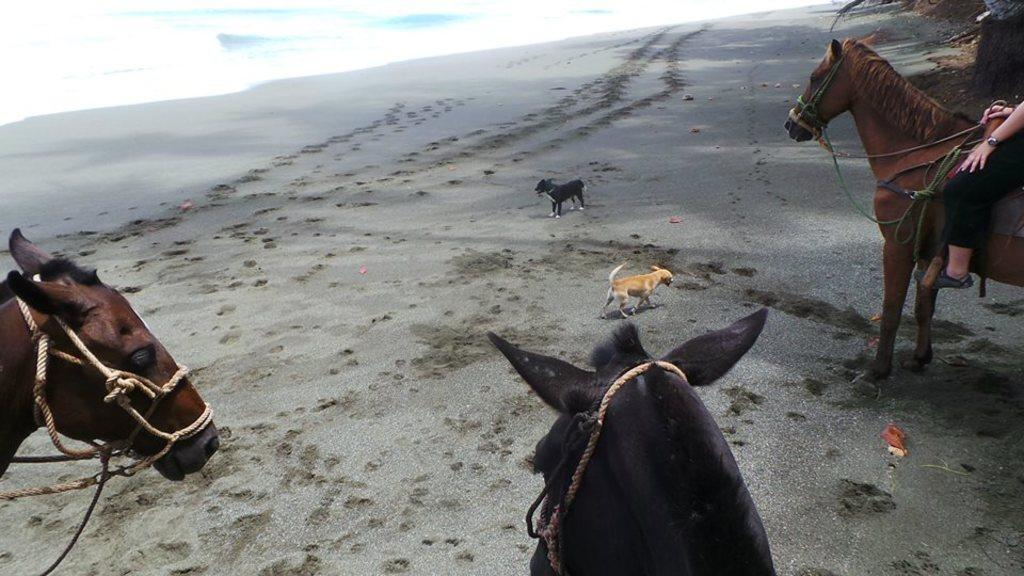How many horses are in the image? There are three horses in the image. What other animals are present in the image? There are two dogs in the image. Where are the animals located? The animals are on the surface of the sand. Is there a person interacting with any of the animals? Yes, there is a person sitting on one of the horses. What can be seen in the background of the image? There is water visible in the background of the image. What is the title of the school that the animals are attending in the image? There is no school or title mentioned in the image; it features animals on the sand. 